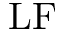Convert formula to latex. <formula><loc_0><loc_0><loc_500><loc_500>L F</formula> 